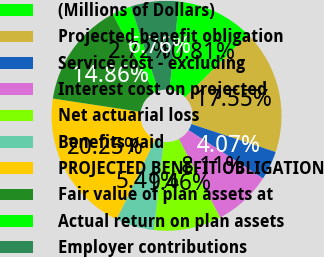Convert chart to OTSL. <chart><loc_0><loc_0><loc_500><loc_500><pie_chart><fcel>(Millions of Dollars)<fcel>Projected benefit obligation<fcel>Service cost - excluding<fcel>Interest cost on projected<fcel>Net actuarial loss<fcel>Benefits paid<fcel>PROJECTED BENEFIT OBLIGATION<fcel>Fair value of plan assets at<fcel>Actual return on plan assets<fcel>Employer contributions<nl><fcel>10.81%<fcel>17.55%<fcel>4.07%<fcel>8.11%<fcel>9.46%<fcel>5.41%<fcel>20.25%<fcel>14.86%<fcel>2.72%<fcel>6.76%<nl></chart> 